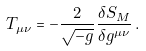<formula> <loc_0><loc_0><loc_500><loc_500>T _ { \mu \nu } = - \frac { 2 } { \sqrt { - g } } \frac { \delta S _ { M } } { \delta g ^ { \mu \nu } } \, .</formula> 